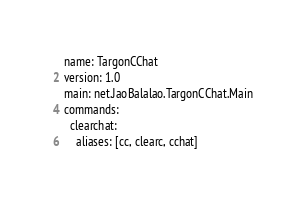Convert code to text. <code><loc_0><loc_0><loc_500><loc_500><_YAML_>name: TargonCChat
version: 1.0
main: net.JaoBalalao.TargonCChat.Main
commands:
  clearchat:
    aliases: [cc, clearc, cchat]</code> 